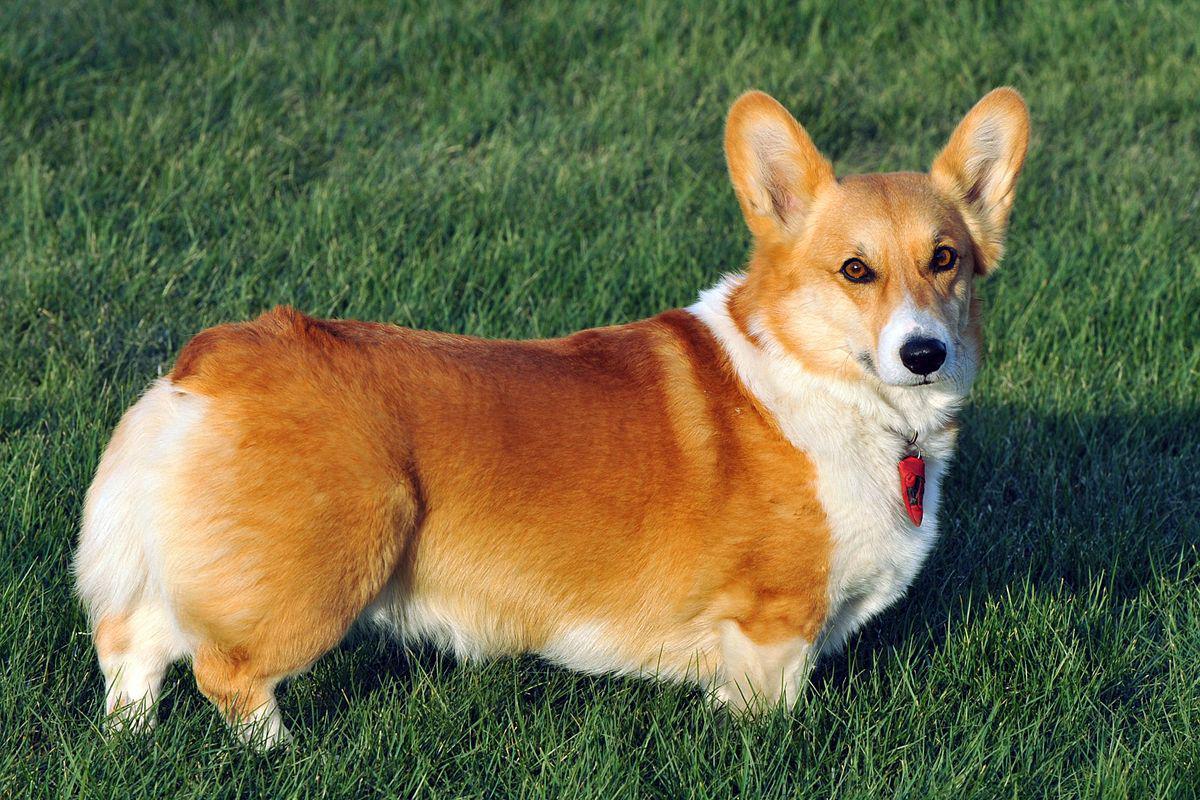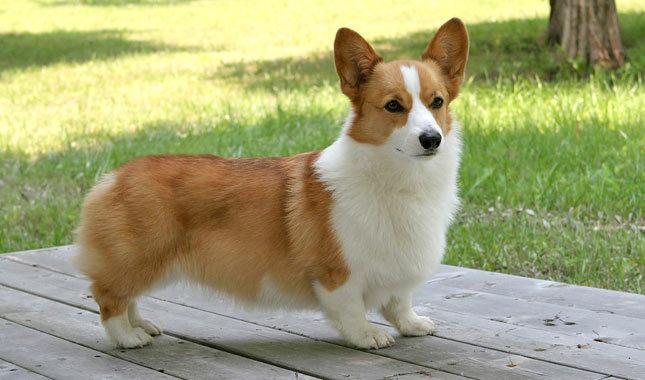The first image is the image on the left, the second image is the image on the right. For the images shown, is this caption "One of the images contains a dog that is sitting." true? Answer yes or no. No. The first image is the image on the left, the second image is the image on the right. Assess this claim about the two images: "The dog standing in the grass is in full profile looking toward the camera.". Correct or not? Answer yes or no. Yes. The first image is the image on the left, the second image is the image on the right. Assess this claim about the two images: "An image shows two big-eared dog faces slide-by-side.". Correct or not? Answer yes or no. No. The first image is the image on the left, the second image is the image on the right. Examine the images to the left and right. Is the description "One of the dogs is standing on all four on the grass." accurate? Answer yes or no. Yes. The first image is the image on the left, the second image is the image on the right. Given the left and right images, does the statement "the dog in the image on the right is in side profile" hold true? Answer yes or no. Yes. The first image is the image on the left, the second image is the image on the right. Given the left and right images, does the statement "All dogs in these images have the same basic pose and fur coloration." hold true? Answer yes or no. Yes. 